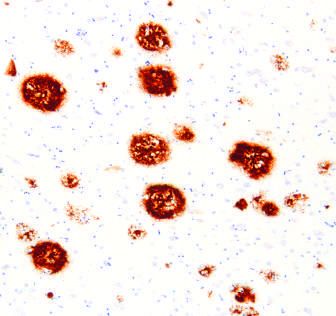does fascicular muscle architecture stain for abeta?
Answer the question using a single word or phrase. No 